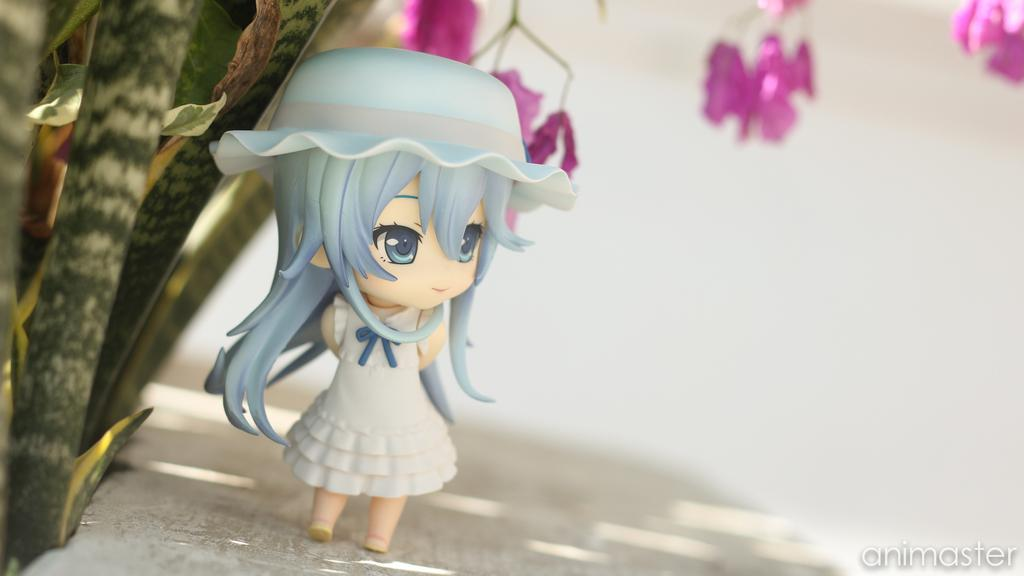What object is placed on a surface in the image? There is a toy on a surface in the image. What type of vegetation is on the left side of the image? There are plants on the left side of the image. What type of flora is visible at the top of the image? There are flowers at the top of the image. How would you describe the background of the image? The background of the image is blurred. Where can text be found in the image? Text is present on the bottom right of the image. Is there any steam visible in the image? No, there is no steam present in the image. 